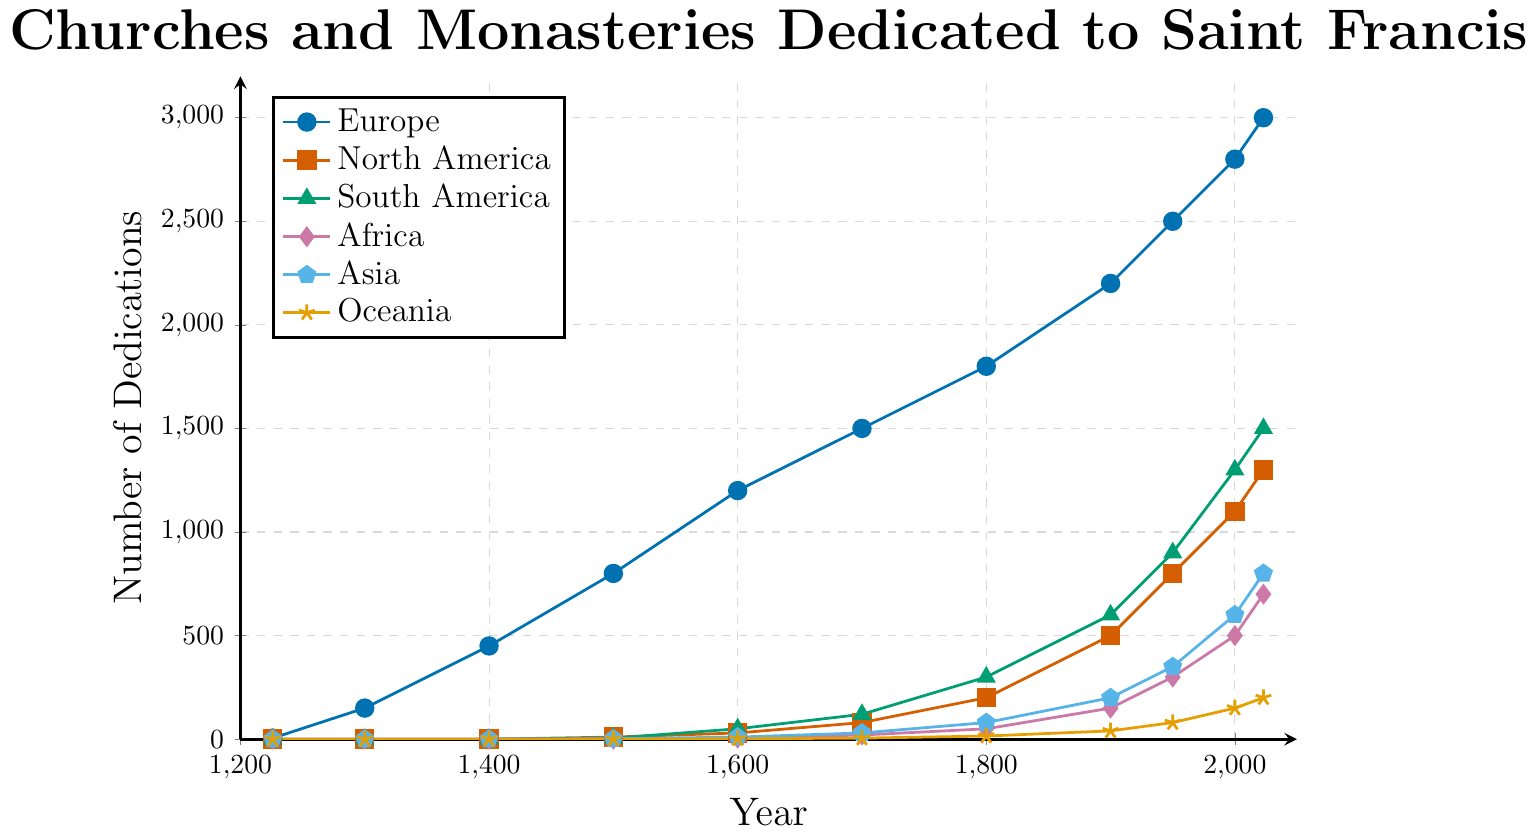What continent had the highest number of dedications in 2023? To determine which continent had the highest number of dedications in 2023, we look at the values for each continent in the year 2023. The chart shows: Europe (3000), North America (1300), South America (1500), Africa (700), Asia (800), and Oceania (200). Europe has the highest number.
Answer: Europe How many dedications in total were there worldwide in 1950? To find the total number of dedications worldwide in 1950, sum the values for each continent for that year: Europe (2500), North America (800), South America (900), Africa (300), Asia (350), and Oceania (80). The total is 2500 + 800 + 900 + 300 + 350 + 80 = 4930.
Answer: 4930 What was the increase in the number of dedications in North America from 1800 to 1900? To calculate the increase, subtract the number of dedications in 1800 from the number in 1900 for North America. The values are 500 (1900) and 200 (1800), so the increase is 500 - 200 = 300.
Answer: 300 Which continent saw the largest relative increase in dedications between 1700 and 1800? To find the largest relative increase, calculate the percentage increase for each continent between 1700 and 1800. Europe: (1800-1500)/1500 = 20%, North America: (200-80)/80= 150%, South America: (300-120)/120 = 150%, Africa: (50-20)/20 = 150%, Asia: (80-30)/30 = 166.67%, Oceania: (15-5)/5 = 200%. Oceania has the largest relative increase.
Answer: Oceania Which continent had the slowest growth rate in dedications between 2000 and 2023? Compare the differences in the number of dedications from 2000 to 2023 for each continent: Europe (3000-2800 = 200), North America (1300-1100 = 200), South America (1500-1300 = 200), Africa (700-500 = 200), Asia (800-600 = 200), and Oceania (200-150 = 50). Oceania had the slowest growth rate.
Answer: Oceania In which period did South America see the most significant growth in dedications? To determine the period of most significant growth for South America, check the intervals between the years that show the increase in number of dedications:  1500-1600 (50-5=45), 1600-1700 (120-50=70), 1700-1800 (300-120=180), 1800-1900 (600-300=300), 1900-1950 (900-600=300), 1950-2000 (1300-900=400), 2000-2023 (1500-1300=200). The largest growth occurred between 1950 and 2000.
Answer: 1950-2000 How does the number of dedications in Africa in 2023 compare to the number in Asia in 1950? The number of dedications in Africa in 2023 is 700, whereas the number in Asia in 1950 is 350. Comparing these, Africa in 2023 has twice the number of dedications compared to Asia in 1950.
Answer: Twice as many in Africa What is the average number of dedications in Europe between 1300 and 1600? To find the average, sum the values for Europe between 1300 and 1600 and then divide by the number of data points. Sum: 150 (1300) + 450 (1400) + 800 (1500) + 1200 (1600) = 2600. Number of data points: 4. Average = 2600/4 = 650.
Answer: 650 